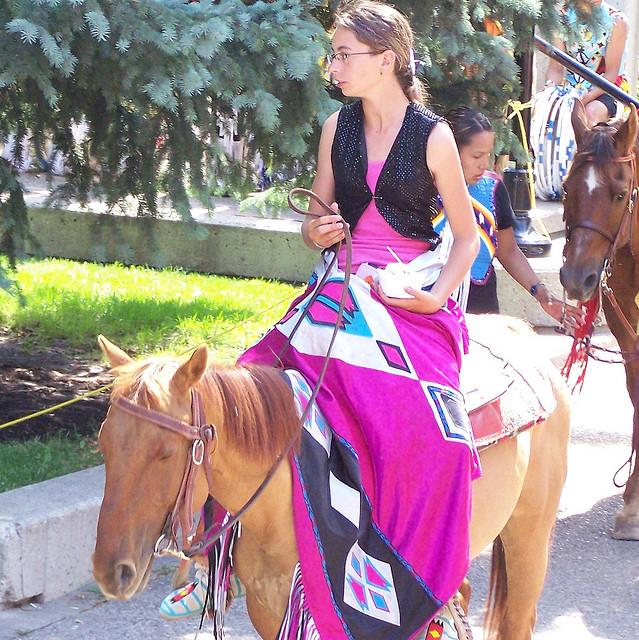What color is her dress?
Keep it brief. Pink. What animal is she riding?
Answer briefly. Horse. How many horses are in the photo?
Answer briefly. 2. Who is on the horse?
Give a very brief answer. Woman. 